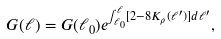Convert formula to latex. <formula><loc_0><loc_0><loc_500><loc_500>G ( \ell ) = G ( \ell _ { 0 } ) e ^ { \int _ { \ell _ { 0 } } ^ { \ell } [ 2 - 8 K _ { \rho } ( \ell ^ { \prime } ) ] d \ell ^ { \prime } } ,</formula> 